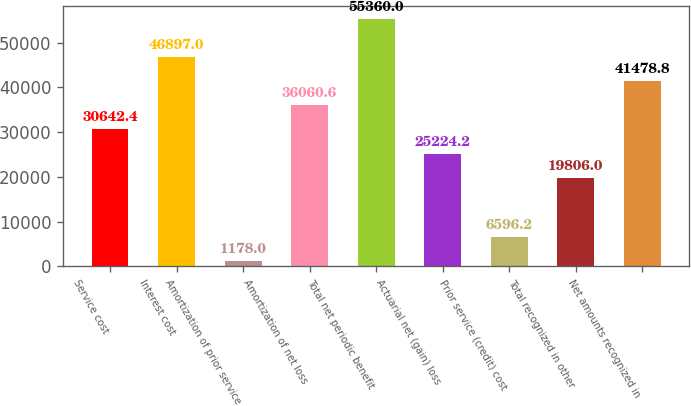Convert chart to OTSL. <chart><loc_0><loc_0><loc_500><loc_500><bar_chart><fcel>Service cost<fcel>Interest cost<fcel>Amortization of prior service<fcel>Amortization of net loss<fcel>Total net periodic benefit<fcel>Actuarial net (gain) loss<fcel>Prior service (credit) cost<fcel>Total recognized in other<fcel>Net amounts recognized in<nl><fcel>30642.4<fcel>46897<fcel>1178<fcel>36060.6<fcel>55360<fcel>25224.2<fcel>6596.2<fcel>19806<fcel>41478.8<nl></chart> 